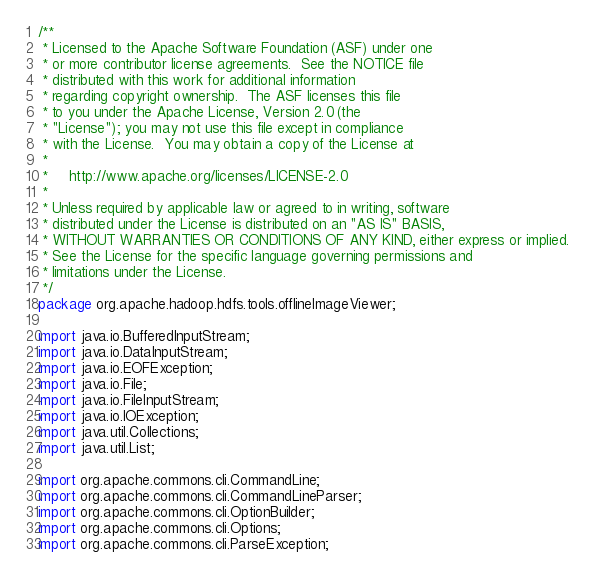<code> <loc_0><loc_0><loc_500><loc_500><_Java_>/**
 * Licensed to the Apache Software Foundation (ASF) under one
 * or more contributor license agreements.  See the NOTICE file
 * distributed with this work for additional information
 * regarding copyright ownership.  The ASF licenses this file
 * to you under the Apache License, Version 2.0 (the
 * "License"); you may not use this file except in compliance
 * with the License.  You may obtain a copy of the License at
 *
 *     http://www.apache.org/licenses/LICENSE-2.0
 *
 * Unless required by applicable law or agreed to in writing, software
 * distributed under the License is distributed on an "AS IS" BASIS,
 * WITHOUT WARRANTIES OR CONDITIONS OF ANY KIND, either express or implied.
 * See the License for the specific language governing permissions and
 * limitations under the License.
 */
package org.apache.hadoop.hdfs.tools.offlineImageViewer;

import java.io.BufferedInputStream;
import java.io.DataInputStream;
import java.io.EOFException;
import java.io.File;
import java.io.FileInputStream;
import java.io.IOException;
import java.util.Collections;
import java.util.List;

import org.apache.commons.cli.CommandLine;
import org.apache.commons.cli.CommandLineParser;
import org.apache.commons.cli.OptionBuilder;
import org.apache.commons.cli.Options;
import org.apache.commons.cli.ParseException;</code> 